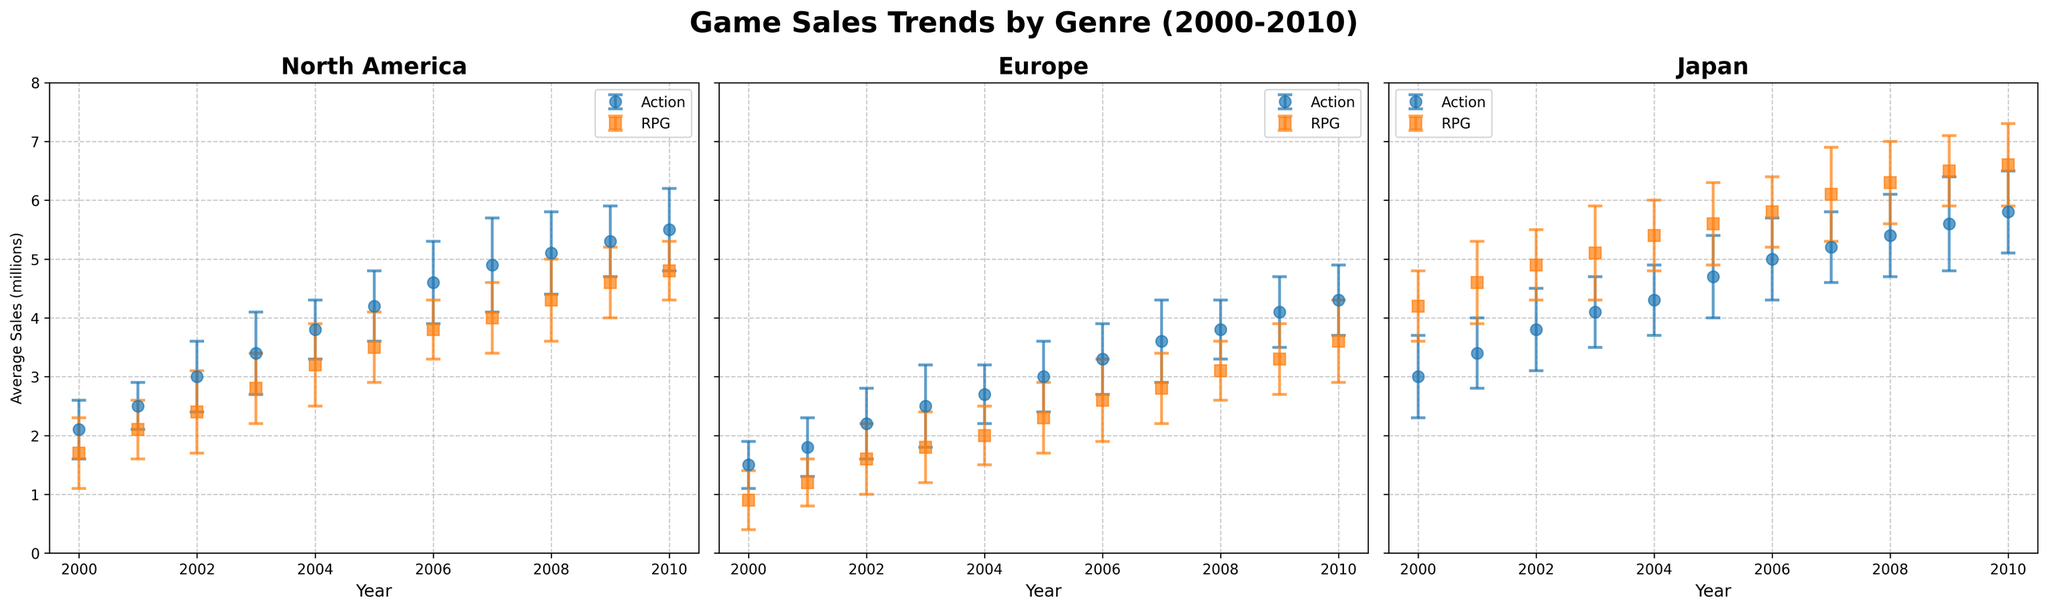What are the average sales for Action games in Japan in 2010? Look at the plot for Japan, find the 2010 point in the Action genre series representing average sales.
Answer: 5.8 million In which region did RPG games have the highest average sales in 2005? Compare the average sales for RPG games across North America, Europe, and Japan in 2005. The highest value is in Japan.
Answer: Japan How do the average sales of Action games in North America in 2000 compare to those in Europe in the same year? Look at the plots for North America and Europe and find the average sales for Action games in 2000. Compare both values: North America has 2.1 million and Europe has 1.5 million. North America's sales are higher.
Answer: Higher in North America Which genre shows more variability in sales in Europe over the years? Look at the error bars across the years for both Action and RPG genres in Europe. The RPG genre has larger error bars indicating higher variability.
Answer: RPG Did average sales for RPG games in Japan ever surpass 6 million during the period 2000-2010? If so, in which years? Look at the plot for Japan, focusing on the RPG genre series. Identify years where the average sales are above 6 million.
Answer: 2007, 2008, 2009, and 2010 What is the trend of average sales for Action games in North America from 2000 to 2010? Observe the plot for North America and follow the line representing Action games from 2000 to 2010. The trend shows an overall increase in average sales.
Answer: Increasing Which genre had a greater increase in average sales in Japan from 2000 to 2010? Calculate the increase in average sales for Action and RPG games in Japan by subtracting their 2000 values from their 2010 values. Action increased from 3.0 to 5.8 (2.8 million increase), and RPG increased from 4.2 to 6.6 (2.4 million increase).
Answer: Action Comparing the standard deviations, which genre seems to have more consistent sales in North America? Look at the error bars for both genres in North America. Smaller and more consistent error bars indicate more consistent sales.
Answer: RPG What are the average sales and standard deviation for Action games in Europe in 2007? Find the plot for Europe and locate the data point for Action games in 2007.
Answer: 3.6 million, 0.7 How do RPG game sales in Japan in 2004 compare to those in North America in 2004? Find the data points for RPG games in both regions for 2004. Japan has 5.4 million and North America has 3.2 million. Japan's sales are higher.
Answer: Higher in Japan 